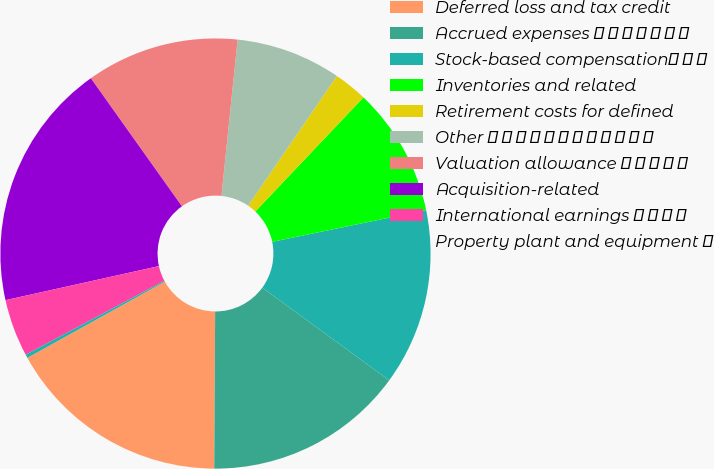Convert chart. <chart><loc_0><loc_0><loc_500><loc_500><pie_chart><fcel>Deferred loss and tax credit<fcel>Accrued expenses � � � � � � �<fcel>Stock-based compensation� � �<fcel>Inventories and related<fcel>Retirement costs for defined<fcel>Other � � � � � � � � � � � �<fcel>Valuation allowance � � � � �<fcel>Acquisition-related<fcel>International earnings � � � �<fcel>Property plant and equipment �<nl><fcel>16.85%<fcel>15.06%<fcel>13.27%<fcel>9.69%<fcel>2.53%<fcel>7.9%<fcel>11.48%<fcel>18.64%<fcel>4.32%<fcel>0.26%<nl></chart> 